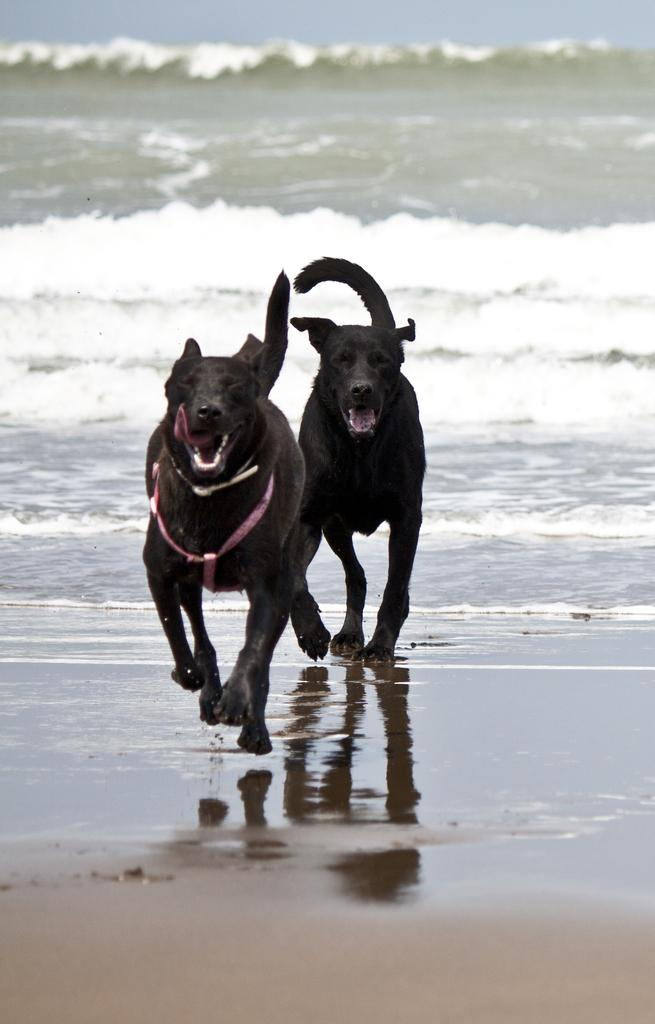How many dogs are present in the image? There are two dogs in the image. What are the dogs doing in the image? The dogs are running in the beach area. What type of digestion system do the dogs have in the image? The image does not provide information about the dogs' digestion systems. Can you tell me who the dogs' friend is in the image? The image does not show any other animals or people that could be considered friends of the dogs. 